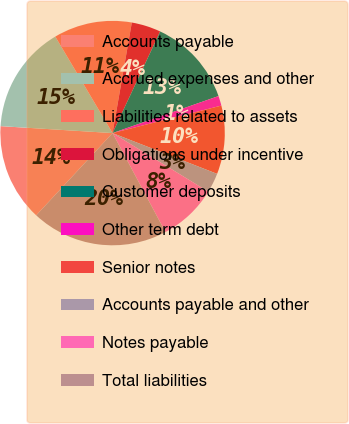Convert chart. <chart><loc_0><loc_0><loc_500><loc_500><pie_chart><fcel>Accounts payable<fcel>Accrued expenses and other<fcel>Liabilities related to assets<fcel>Obligations under incentive<fcel>Customer deposits<fcel>Other term debt<fcel>Senior notes<fcel>Accounts payable and other<fcel>Notes payable<fcel>Total liabilities<nl><fcel>14.08%<fcel>15.49%<fcel>11.27%<fcel>4.23%<fcel>12.68%<fcel>1.41%<fcel>9.86%<fcel>2.82%<fcel>8.45%<fcel>19.72%<nl></chart> 